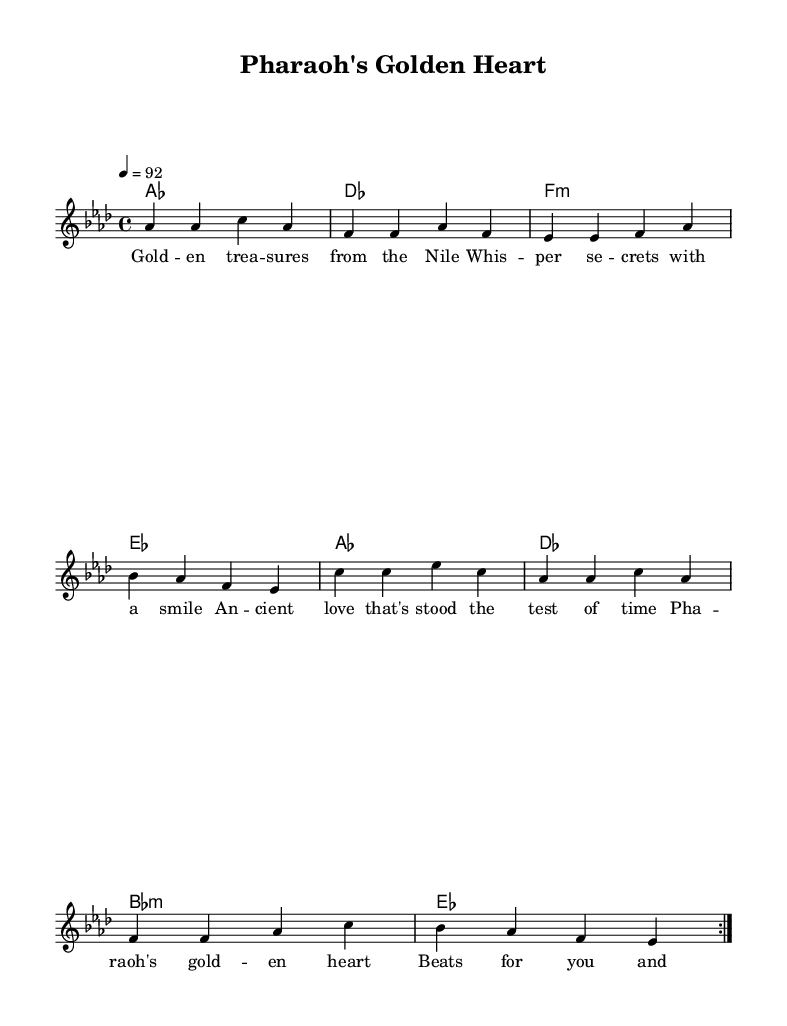What is the key signature of this music? The key signature is A flat major, which has four flats: B flat, E flat, A flat, and D flat.
Answer: A flat major What is the time signature of this music? The time signature is indicated as 4/4, meaning there are four beats in each measure.
Answer: 4/4 What is the tempo marking for this piece? The tempo is marked as quarter note equals 92, which establishes the speed of the music.
Answer: 92 How many measures are in the verse section? The verse section contains 4 measures in total, as noted in the repeated volta instruction.
Answer: 4 What is the main theme of the lyrics? The lyrics focus on ancient love and treasures, drawing a connection to ancient Egypt with metaphors.
Answer: Ancient love What type of chords are used in the harmonies for the chorus? The chorus features major and minor chords, specifically A flat major, B flat minor, and E flat major.
Answer: Major and minor How does the repeated volta affect the structure? The repeated volta indicates that the verse will be played twice, creating a fuller musical form before moving on to the chorus.
Answer: Twice 